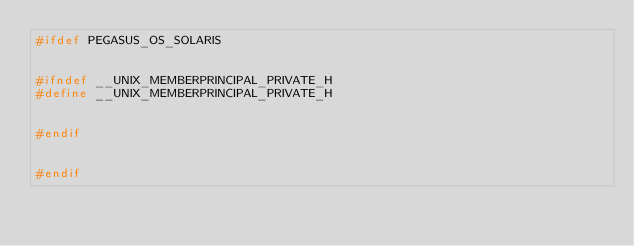Convert code to text. <code><loc_0><loc_0><loc_500><loc_500><_C++_>#ifdef PEGASUS_OS_SOLARIS


#ifndef __UNIX_MEMBERPRINCIPAL_PRIVATE_H
#define __UNIX_MEMBERPRINCIPAL_PRIVATE_H


#endif


#endif
</code> 